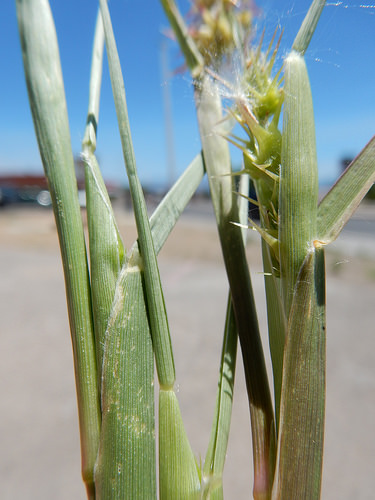<image>
Is the thorn to the right of the plant? No. The thorn is not to the right of the plant. The horizontal positioning shows a different relationship. 